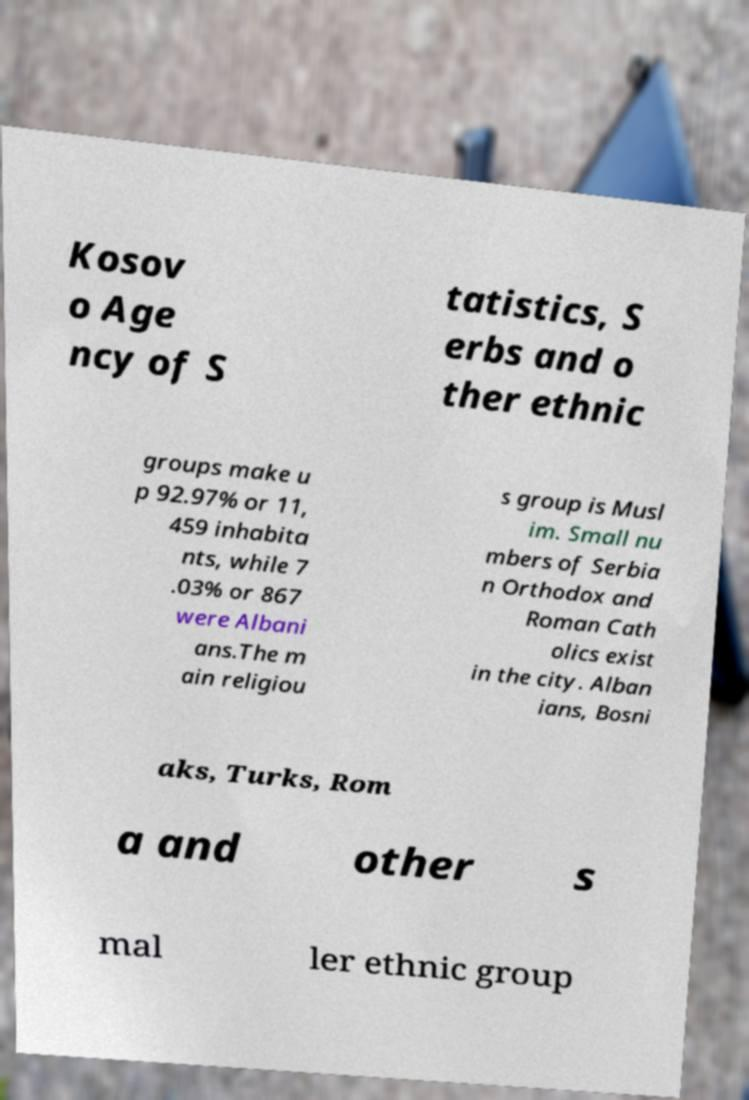There's text embedded in this image that I need extracted. Can you transcribe it verbatim? Kosov o Age ncy of S tatistics, S erbs and o ther ethnic groups make u p 92.97% or 11, 459 inhabita nts, while 7 .03% or 867 were Albani ans.The m ain religiou s group is Musl im. Small nu mbers of Serbia n Orthodox and Roman Cath olics exist in the city. Alban ians, Bosni aks, Turks, Rom a and other s mal ler ethnic group 